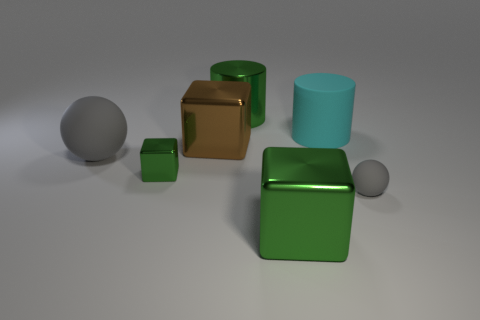Add 3 purple shiny things. How many objects exist? 10 Subtract all cubes. How many objects are left? 4 Add 1 small blocks. How many small blocks are left? 2 Add 3 purple shiny balls. How many purple shiny balls exist? 3 Subtract 0 purple cylinders. How many objects are left? 7 Subtract all cylinders. Subtract all small gray matte objects. How many objects are left? 4 